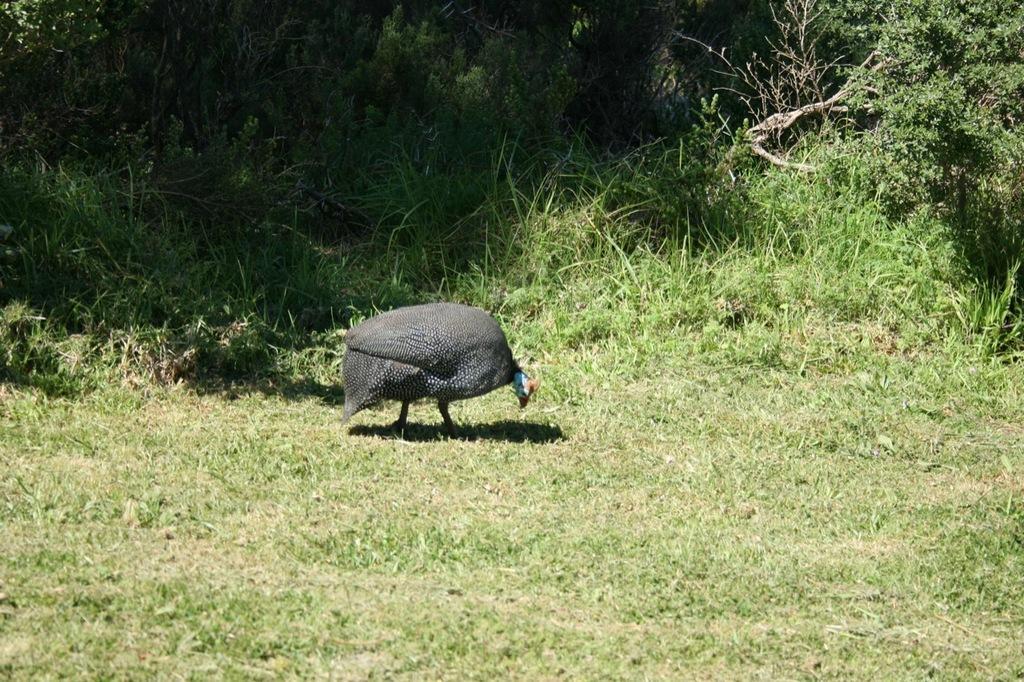In one or two sentences, can you explain what this image depicts? In this picture there is a bird standing. At the back there are trees. At the bottom there is grass. 